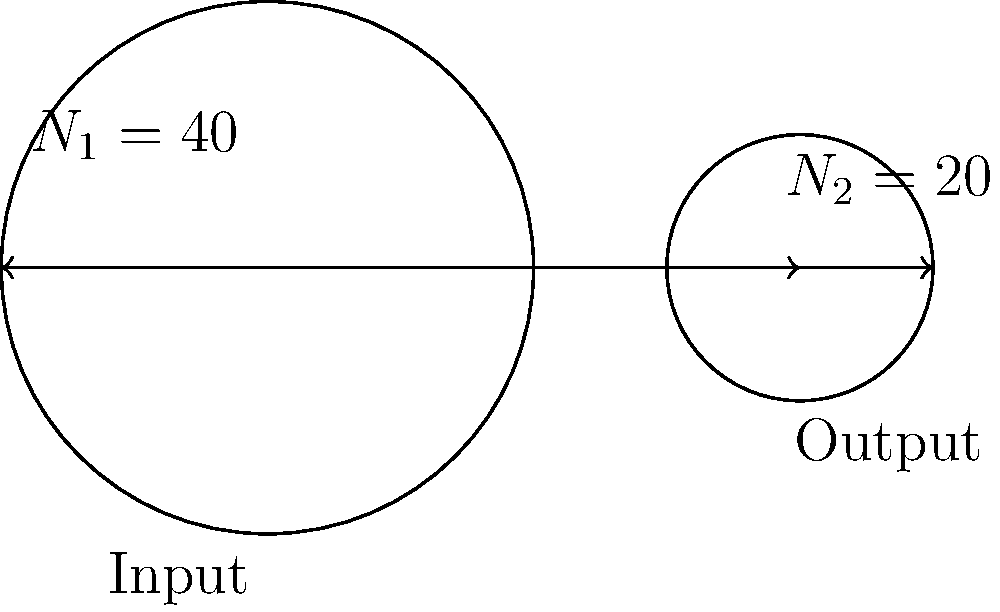In the gear system shown, the input gear has 40 teeth ($N_1 = 40$) and the output gear has 20 teeth ($N_2 = 20$). If the input torque is 100 Nm, what is the output torque? How does this relate to the concept of mechanical advantage in gear systems? To solve this problem, we'll follow these steps:

1) First, recall the fundamental relationship between gear ratios and torque:

   $\frac{T_2}{T_1} = \frac{N_1}{N_2}$

   Where $T_1$ and $T_2$ are input and output torques, and $N_1$ and $N_2$ are the number of teeth on the input and output gears respectively.

2) We're given:
   $N_1 = 40$
   $N_2 = 20$
   $T_1 = 100$ Nm (input torque)

3) Substituting these values into our equation:

   $\frac{T_2}{100} = \frac{40}{20}$

4) Simplify the right side:

   $\frac{T_2}{100} = 2$

5) Solve for $T_2$:

   $T_2 = 100 * 2 = 200$ Nm

6) Regarding mechanical advantage:
   The gear ratio ($\frac{N_1}{N_2}$) is 2, which means the output gear rotates twice as fast as the input gear. However, it also means that the output torque is twice the input torque. This illustrates the principle of mechanical advantage in gear systems: we can trade speed for torque, or vice versa. In this case, we've gained torque at the expense of speed.
Answer: 200 Nm; It demonstrates mechanical advantage by trading speed for increased torque. 